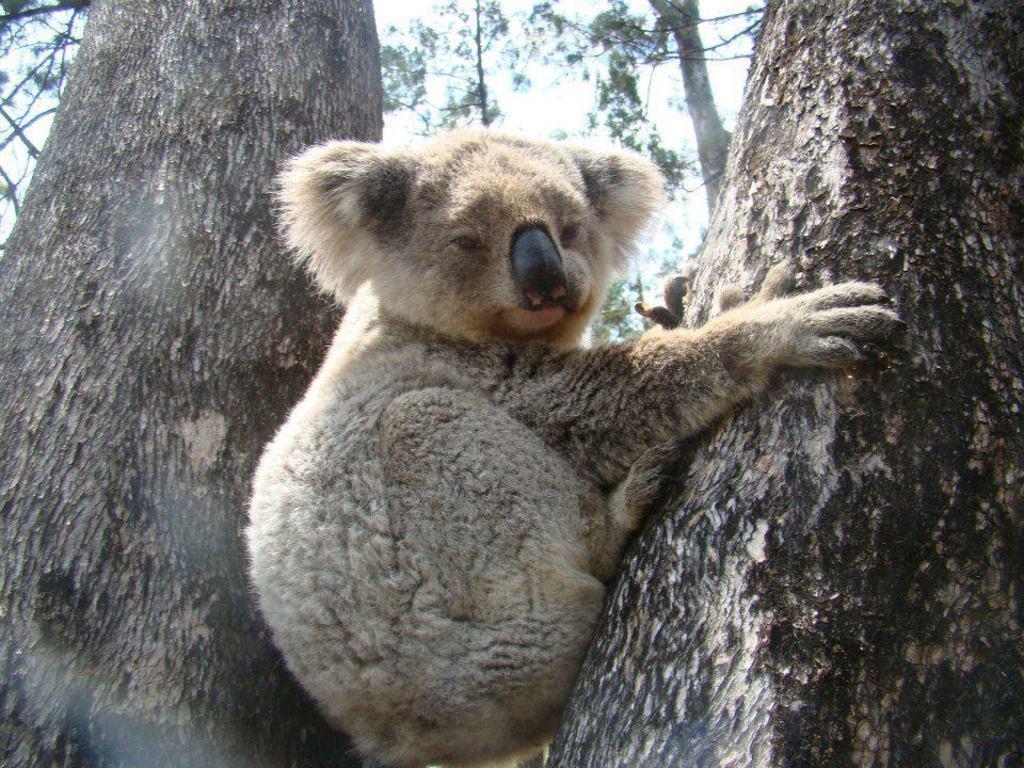Describe this image in one or two sentences. In this image we can see an animal in between the two trees and on the right side tree. In the background there are trees and sky. 